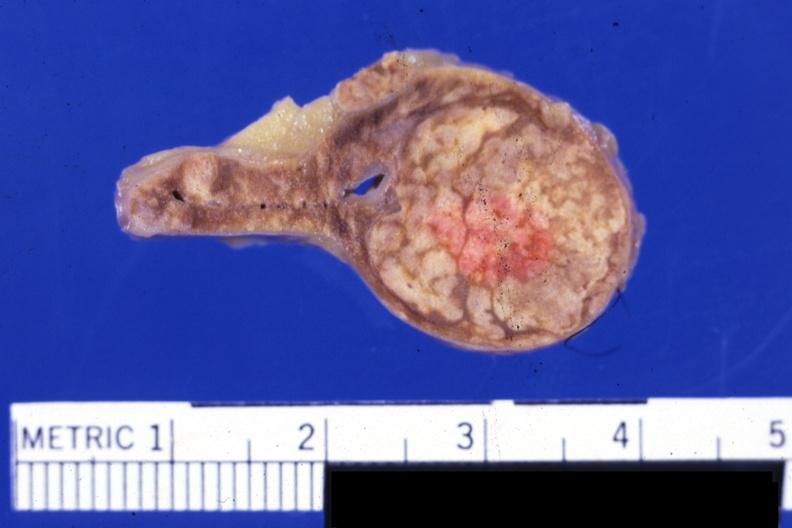where does this belong to?
Answer the question using a single word or phrase. Endocrine system 